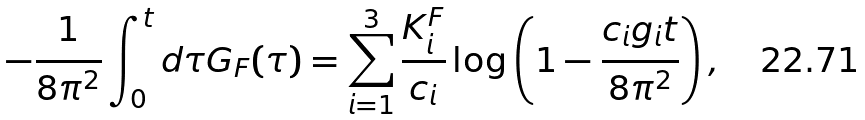<formula> <loc_0><loc_0><loc_500><loc_500>- \frac { 1 } { 8 { \pi } ^ { 2 } } \int _ { 0 } ^ { t } d \tau G _ { F } ( \tau ) = \sum _ { i = 1 } ^ { 3 } \frac { K _ { i } ^ { F } } { c _ { i } } \log \left ( 1 - \frac { c _ { i } g _ { i } t } { 8 \pi ^ { 2 } } \right ) ,</formula> 